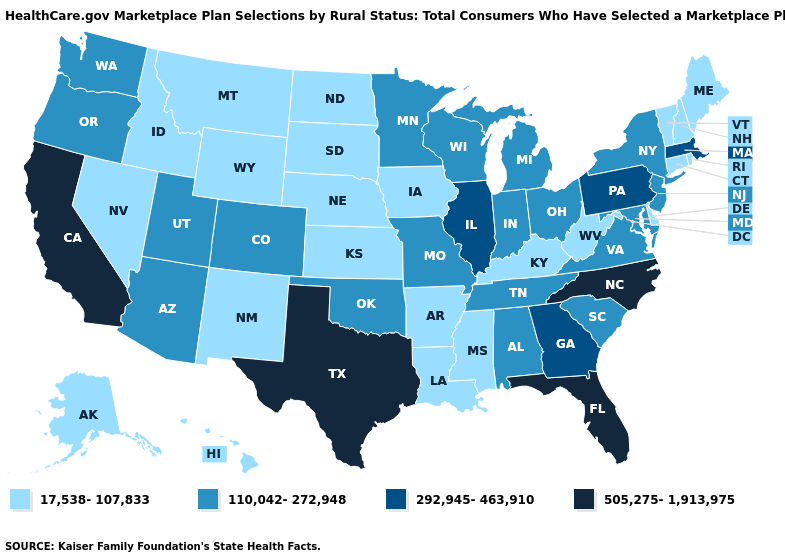What is the highest value in the USA?
Concise answer only. 505,275-1,913,975. What is the value of Minnesota?
Quick response, please. 110,042-272,948. Does North Carolina have the highest value in the USA?
Write a very short answer. Yes. Does Arizona have the highest value in the USA?
Keep it brief. No. Does New York have the same value as New Jersey?
Concise answer only. Yes. What is the value of Maryland?
Write a very short answer. 110,042-272,948. Name the states that have a value in the range 17,538-107,833?
Give a very brief answer. Alaska, Arkansas, Connecticut, Delaware, Hawaii, Idaho, Iowa, Kansas, Kentucky, Louisiana, Maine, Mississippi, Montana, Nebraska, Nevada, New Hampshire, New Mexico, North Dakota, Rhode Island, South Dakota, Vermont, West Virginia, Wyoming. Name the states that have a value in the range 505,275-1,913,975?
Keep it brief. California, Florida, North Carolina, Texas. What is the lowest value in states that border South Carolina?
Be succinct. 292,945-463,910. Name the states that have a value in the range 110,042-272,948?
Short answer required. Alabama, Arizona, Colorado, Indiana, Maryland, Michigan, Minnesota, Missouri, New Jersey, New York, Ohio, Oklahoma, Oregon, South Carolina, Tennessee, Utah, Virginia, Washington, Wisconsin. What is the highest value in the USA?
Quick response, please. 505,275-1,913,975. What is the value of Tennessee?
Quick response, please. 110,042-272,948. What is the value of Hawaii?
Give a very brief answer. 17,538-107,833. Does North Carolina have the highest value in the USA?
Keep it brief. Yes. 